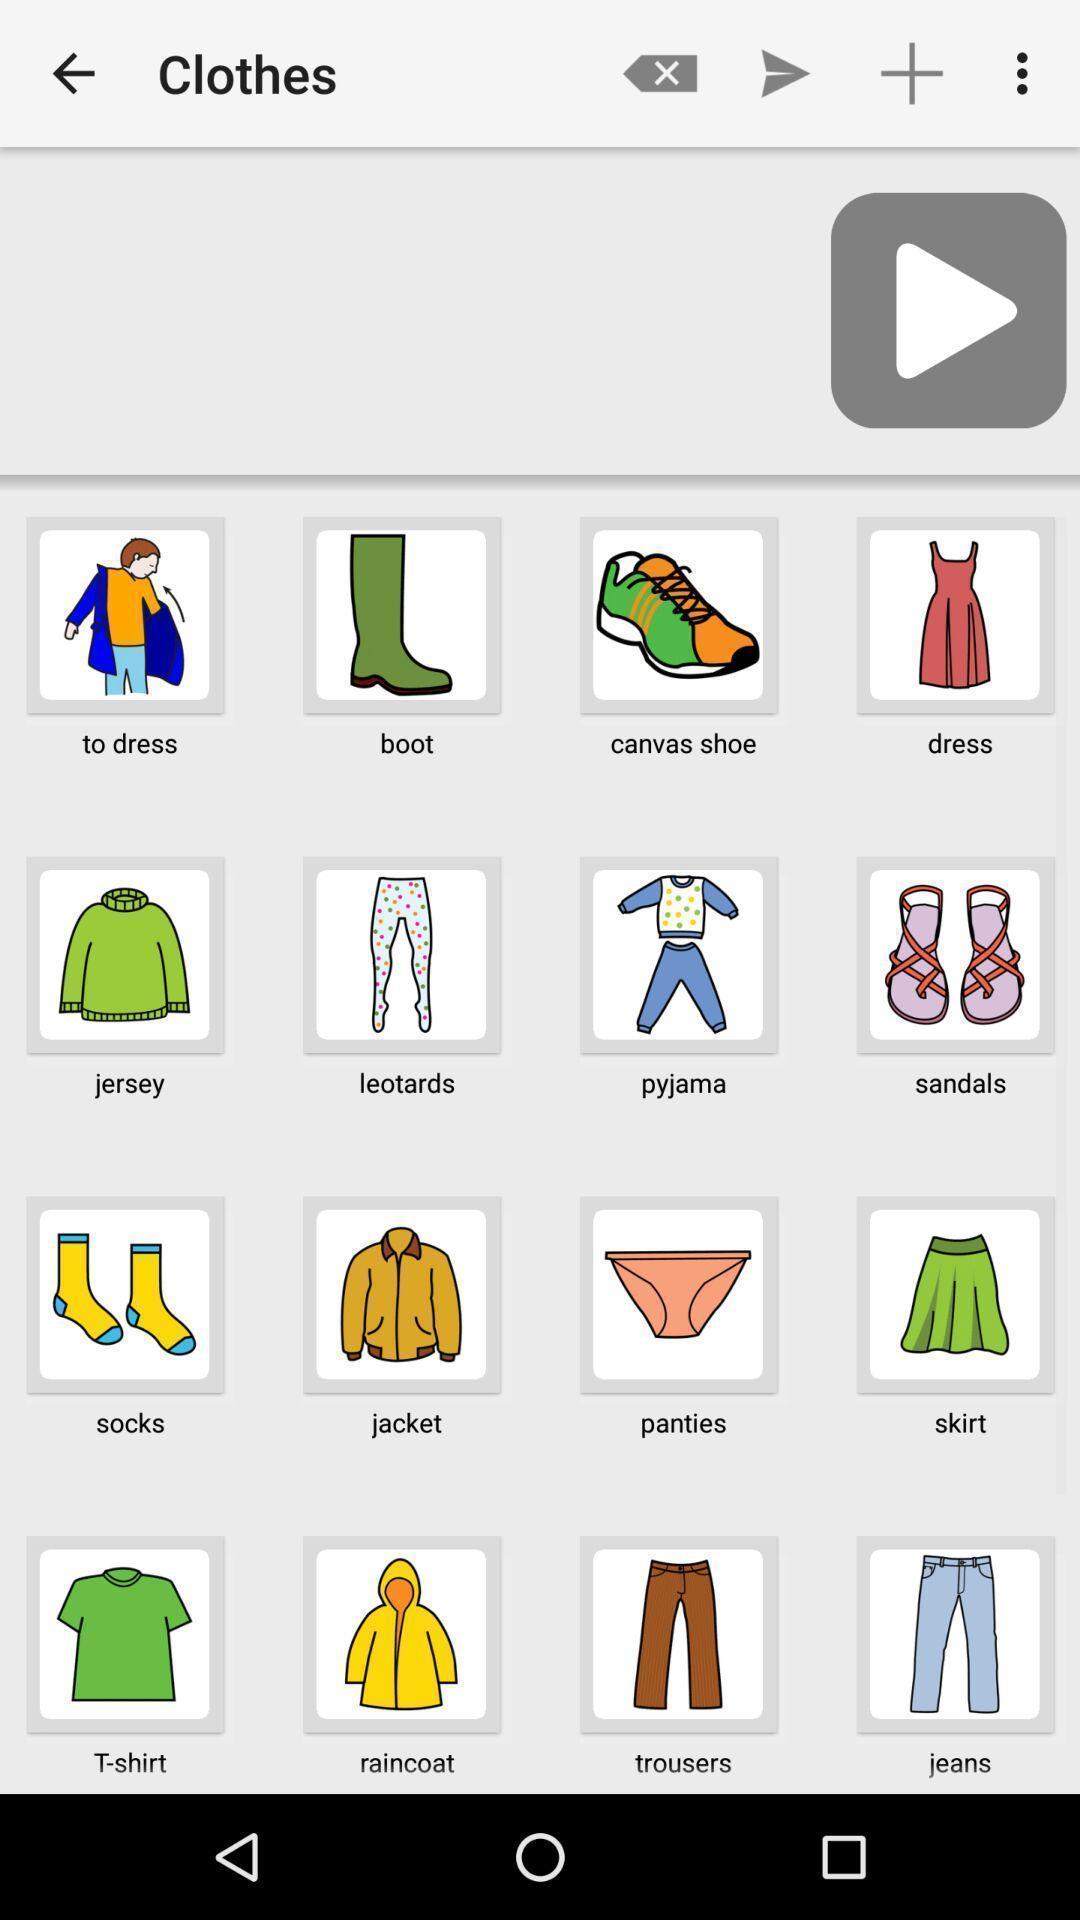Explain what's happening in this screen capture. Screen displaying the list of categories. 